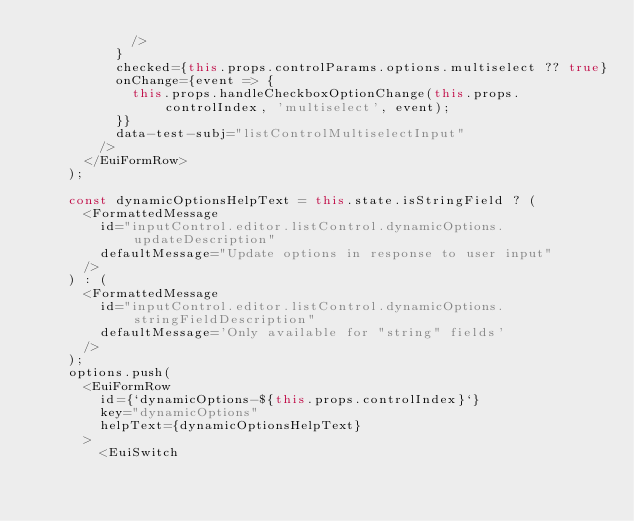<code> <loc_0><loc_0><loc_500><loc_500><_TypeScript_>            />
          }
          checked={this.props.controlParams.options.multiselect ?? true}
          onChange={event => {
            this.props.handleCheckboxOptionChange(this.props.controlIndex, 'multiselect', event);
          }}
          data-test-subj="listControlMultiselectInput"
        />
      </EuiFormRow>
    );

    const dynamicOptionsHelpText = this.state.isStringField ? (
      <FormattedMessage
        id="inputControl.editor.listControl.dynamicOptions.updateDescription"
        defaultMessage="Update options in response to user input"
      />
    ) : (
      <FormattedMessage
        id="inputControl.editor.listControl.dynamicOptions.stringFieldDescription"
        defaultMessage='Only available for "string" fields'
      />
    );
    options.push(
      <EuiFormRow
        id={`dynamicOptions-${this.props.controlIndex}`}
        key="dynamicOptions"
        helpText={dynamicOptionsHelpText}
      >
        <EuiSwitch</code> 